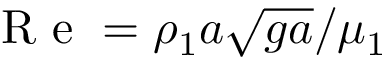Convert formula to latex. <formula><loc_0><loc_0><loc_500><loc_500>R e = \rho _ { 1 } a \sqrt { g a } / \mu _ { 1 }</formula> 